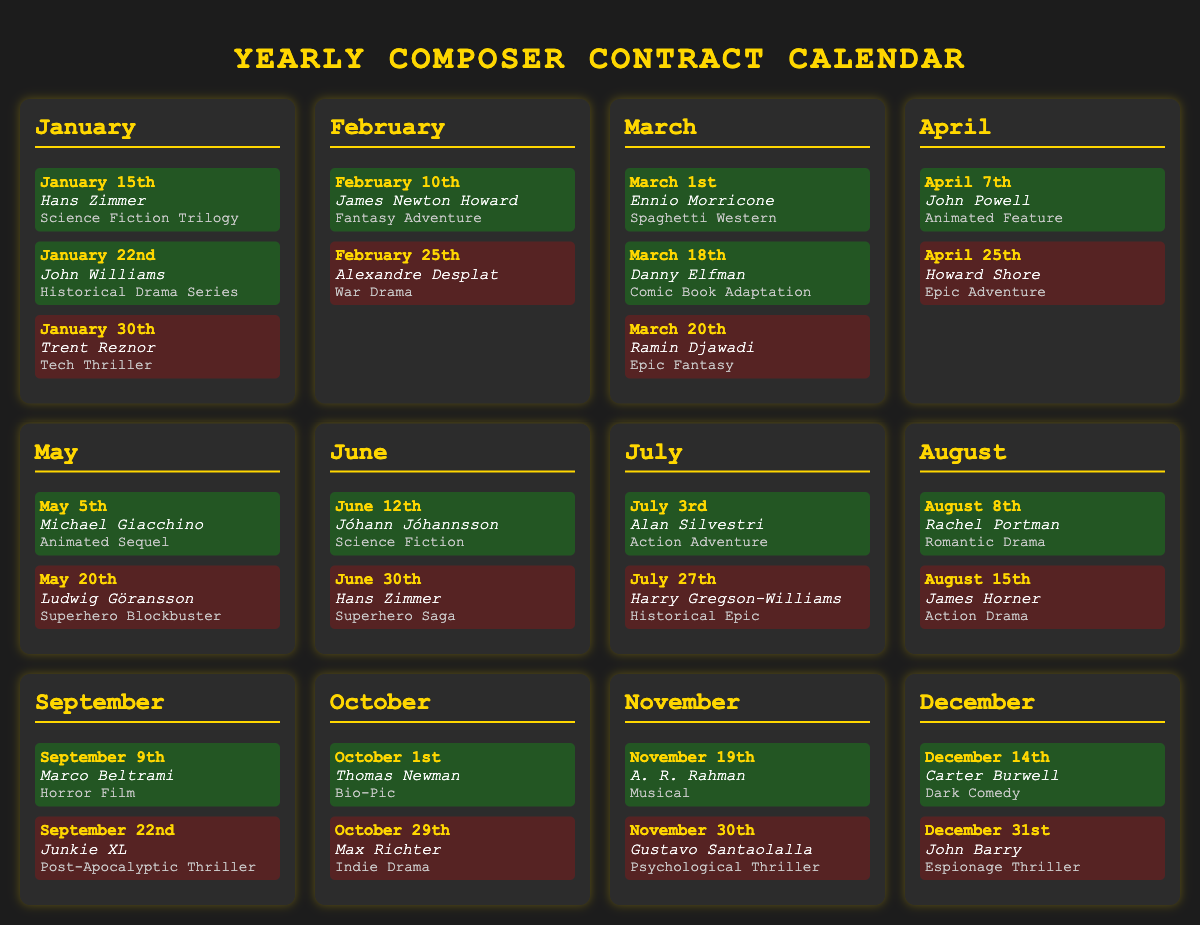What is the date for Hans Zimmer's contract renewal? The document states that Hans Zimmer's contract renewal is on January 15th.
Answer: January 15th How many composers have a contract expiration in May? The document lists one expiration event in May, which is for Ludwig Göransson on May 20th.
Answer: 1 Which project is associated with John Williams? John Williams' project listed is "Historical Drama Series."
Answer: Historical Drama Series What is the total number of renewal events in December? There is one renewal event in December for Carter Burwell on December 14th.
Answer: 1 Who has a contract expiration on March 20th? Ramin Djawadi has a contract expiration on March 20th.
Answer: Ramin Djawadi Which composer is associated with the project "Superhero Saga"? The project "Superhero Saga" is associated with Hans Zimmer.
Answer: Hans Zimmer What type of film is Rachel Portman's associated project? Rachel Portman is associated with a "Romantic Drama."
Answer: Romantic Drama How many composers have events in September? There are two events in September; one renewal for Marco Beltrami and one expiration for Junkie XL.
Answer: 2 What is the project associated with Max Richter's expiration? Max Richter's expiration is associated with the project "Indie Drama."
Answer: Indie Drama 